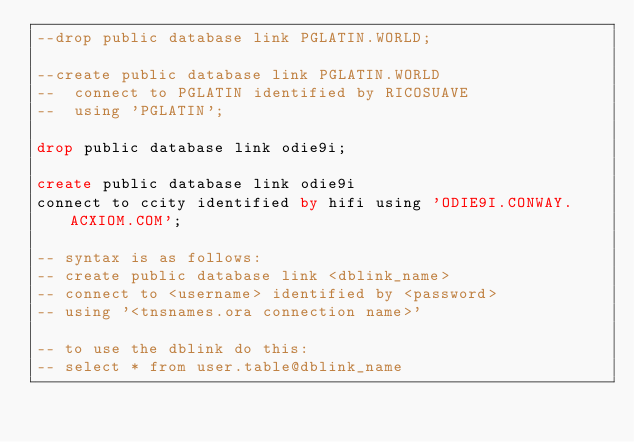<code> <loc_0><loc_0><loc_500><loc_500><_SQL_>--drop public database link PGLATIN.WORLD;

--create public database link PGLATIN.WORLD
--  connect to PGLATIN identified by RICOSUAVE
--  using 'PGLATIN';

drop public database link odie9i;

create public database link odie9i
connect to ccity identified by hifi using 'ODIE9I.CONWAY.ACXIOM.COM';

-- syntax is as follows:
-- create public database link <dblink_name>
-- connect to <username> identified by <password>
-- using '<tnsnames.ora connection name>'

-- to use the dblink do this:
-- select * from user.table@dblink_name

</code> 